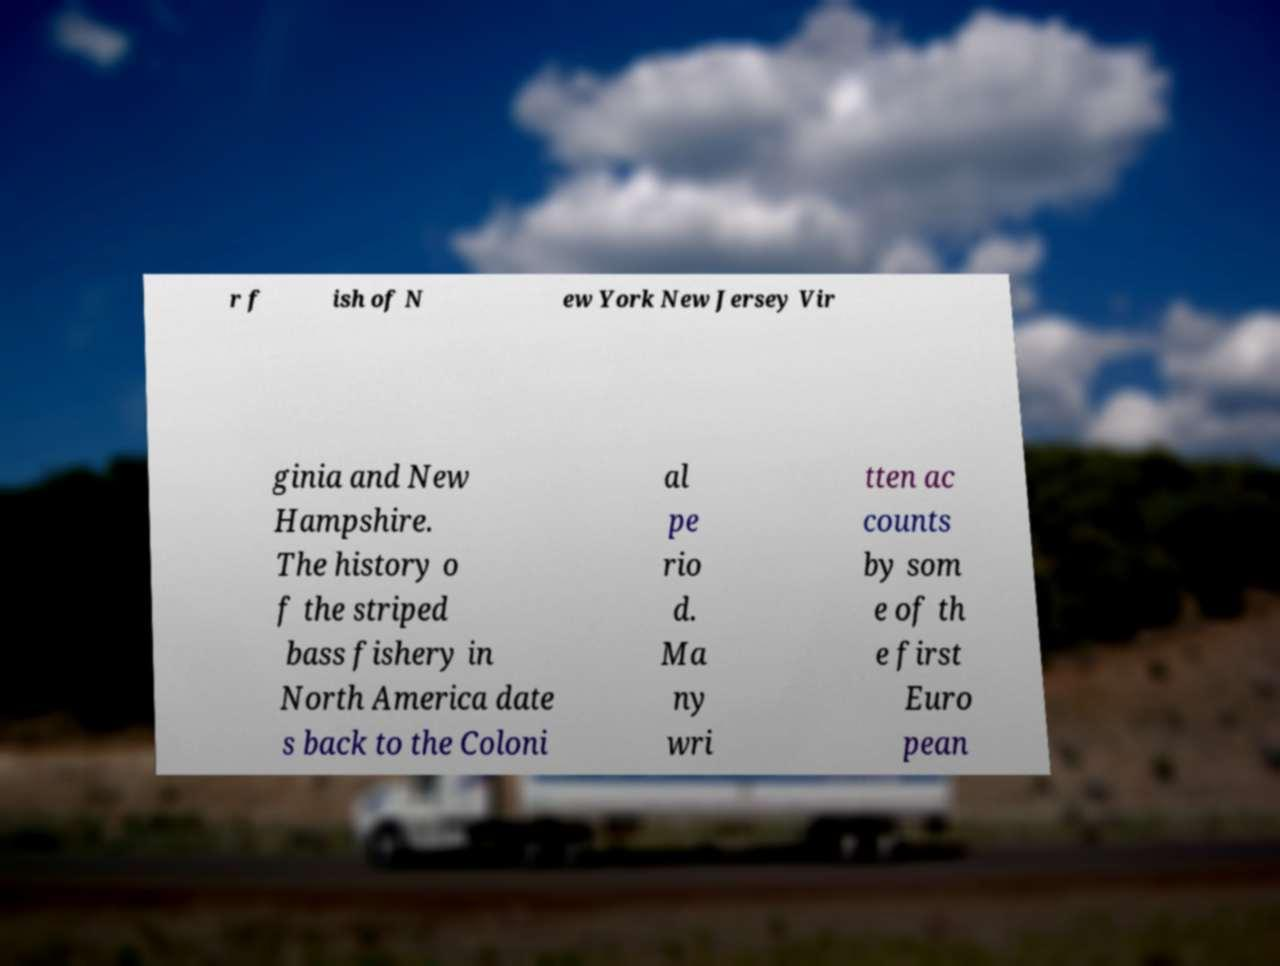Can you accurately transcribe the text from the provided image for me? r f ish of N ew York New Jersey Vir ginia and New Hampshire. The history o f the striped bass fishery in North America date s back to the Coloni al pe rio d. Ma ny wri tten ac counts by som e of th e first Euro pean 